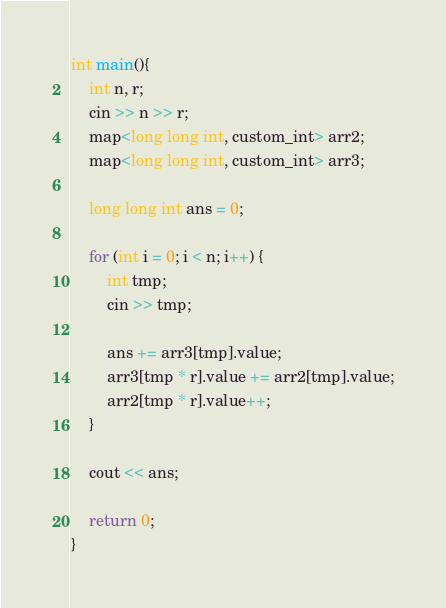Convert code to text. <code><loc_0><loc_0><loc_500><loc_500><_C++_>int main(){
    int n, r;
    cin >> n >> r;
    map<long long int, custom_int> arr2;
    map<long long int, custom_int> arr3;

    long long int ans = 0;

    for (int i = 0; i < n; i++) {
        int tmp;
        cin >> tmp;

        ans += arr3[tmp].value;
        arr3[tmp * r].value += arr2[tmp].value;
        arr2[tmp * r].value++;
    }

    cout << ans;

    return 0;
}
</code> 